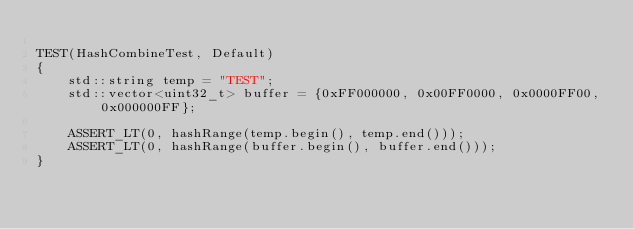Convert code to text. <code><loc_0><loc_0><loc_500><loc_500><_C++_>
TEST(HashCombineTest, Default)
{
    std::string temp = "TEST";
    std::vector<uint32_t> buffer = {0xFF000000, 0x00FF0000, 0x0000FF00, 0x000000FF};

    ASSERT_LT(0, hashRange(temp.begin(), temp.end()));
    ASSERT_LT(0, hashRange(buffer.begin(), buffer.end()));
}

</code> 